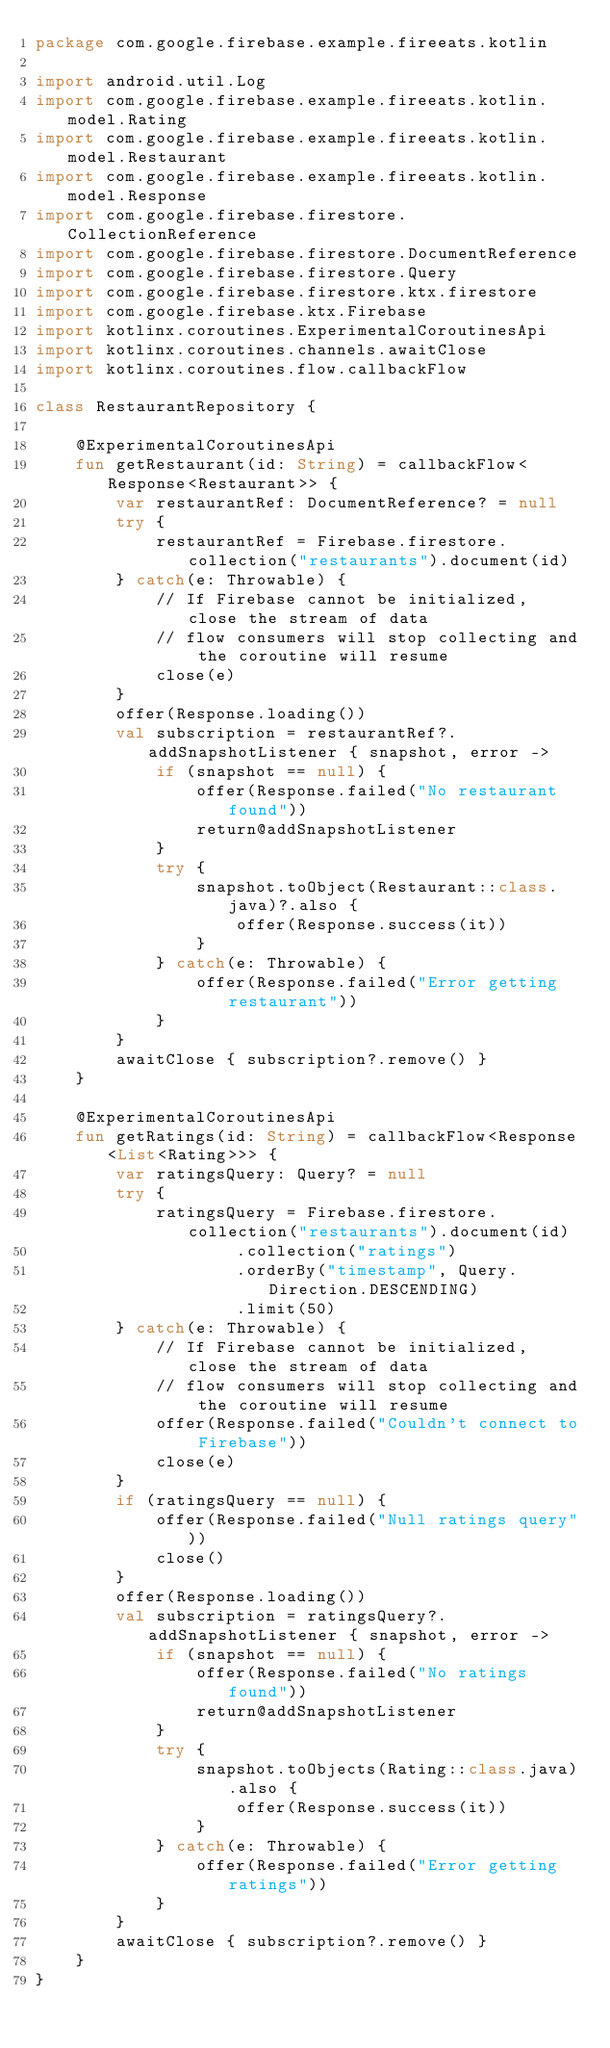Convert code to text. <code><loc_0><loc_0><loc_500><loc_500><_Kotlin_>package com.google.firebase.example.fireeats.kotlin

import android.util.Log
import com.google.firebase.example.fireeats.kotlin.model.Rating
import com.google.firebase.example.fireeats.kotlin.model.Restaurant
import com.google.firebase.example.fireeats.kotlin.model.Response
import com.google.firebase.firestore.CollectionReference
import com.google.firebase.firestore.DocumentReference
import com.google.firebase.firestore.Query
import com.google.firebase.firestore.ktx.firestore
import com.google.firebase.ktx.Firebase
import kotlinx.coroutines.ExperimentalCoroutinesApi
import kotlinx.coroutines.channels.awaitClose
import kotlinx.coroutines.flow.callbackFlow

class RestaurantRepository {

    @ExperimentalCoroutinesApi
    fun getRestaurant(id: String) = callbackFlow<Response<Restaurant>> {
        var restaurantRef: DocumentReference? = null
        try {
            restaurantRef = Firebase.firestore.collection("restaurants").document(id)
        } catch(e: Throwable) {
            // If Firebase cannot be initialized, close the stream of data
            // flow consumers will stop collecting and the coroutine will resume
            close(e)
        }
        offer(Response.loading())
        val subscription = restaurantRef?.addSnapshotListener { snapshot, error ->
            if (snapshot == null) {
                offer(Response.failed("No restaurant found"))
                return@addSnapshotListener
            }
            try {
                snapshot.toObject(Restaurant::class.java)?.also {
                    offer(Response.success(it))
                }
            } catch(e: Throwable) {
                offer(Response.failed("Error getting restaurant"))
            }
        }
        awaitClose { subscription?.remove() }
    }

    @ExperimentalCoroutinesApi
    fun getRatings(id: String) = callbackFlow<Response<List<Rating>>> {
        var ratingsQuery: Query? = null
        try {
            ratingsQuery = Firebase.firestore.collection("restaurants").document(id)
                    .collection("ratings")
                    .orderBy("timestamp", Query.Direction.DESCENDING)
                    .limit(50)
        } catch(e: Throwable) {
            // If Firebase cannot be initialized, close the stream of data
            // flow consumers will stop collecting and the coroutine will resume
            offer(Response.failed("Couldn't connect to Firebase"))
            close(e)
        }
        if (ratingsQuery == null) {
            offer(Response.failed("Null ratings query"))
            close()
        }
        offer(Response.loading())
        val subscription = ratingsQuery?.addSnapshotListener { snapshot, error ->
            if (snapshot == null) {
                offer(Response.failed("No ratings found"))
                return@addSnapshotListener
            }
            try {
                snapshot.toObjects(Rating::class.java).also {
                    offer(Response.success(it))
                }
            } catch(e: Throwable) {
                offer(Response.failed("Error getting ratings"))
            }
        }
        awaitClose { subscription?.remove() }
    }
}</code> 